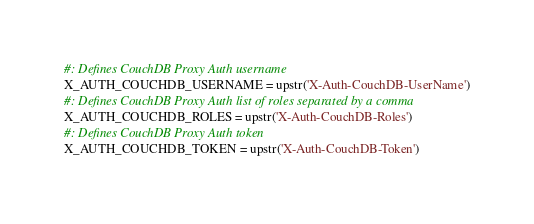Convert code to text. <code><loc_0><loc_0><loc_500><loc_500><_Python_>
#: Defines CouchDB Proxy Auth username
X_AUTH_COUCHDB_USERNAME = upstr('X-Auth-CouchDB-UserName')
#: Defines CouchDB Proxy Auth list of roles separated by a comma
X_AUTH_COUCHDB_ROLES = upstr('X-Auth-CouchDB-Roles')
#: Defines CouchDB Proxy Auth token
X_AUTH_COUCHDB_TOKEN = upstr('X-Auth-CouchDB-Token')
</code> 